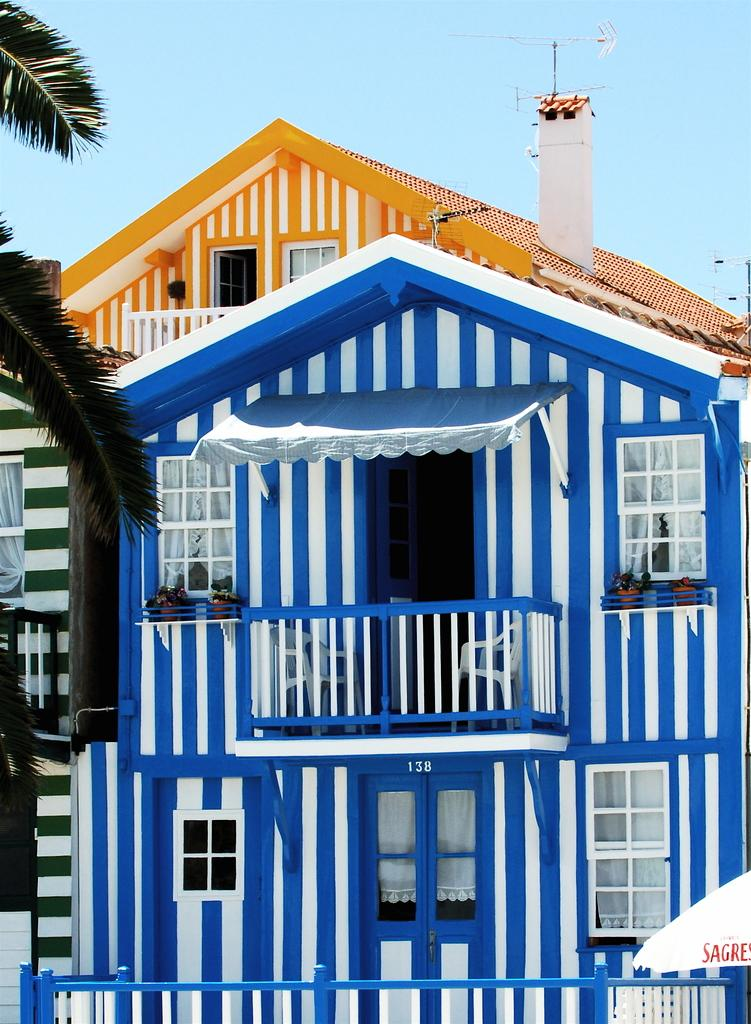What type of structure is in the image? There is a building in the image. What features can be seen on the building? The building has windows and doors. Where is the tree located in the image? The tree is in the top left corner of the image. What can be seen in the background of the image? The sky is visible in the background of the image. What type of canvas is used to create the mountain in the image? There is no mountain present in the image, and therefore no canvas is used to create it. 